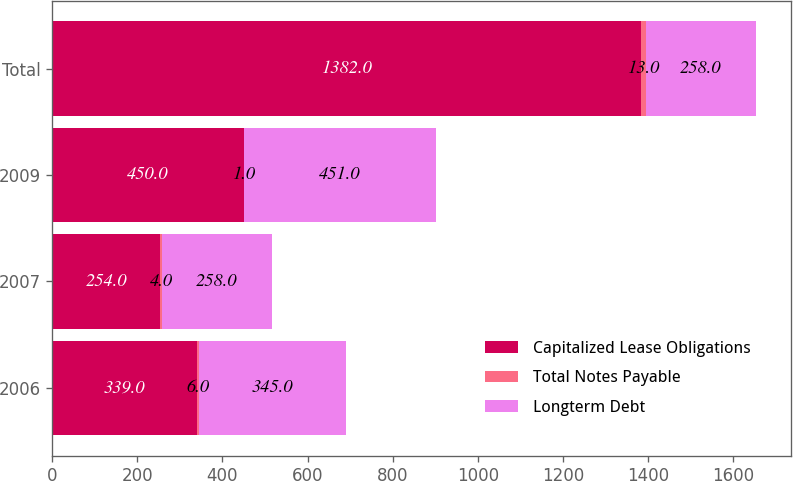Convert chart. <chart><loc_0><loc_0><loc_500><loc_500><stacked_bar_chart><ecel><fcel>2006<fcel>2007<fcel>2009<fcel>Total<nl><fcel>Capitalized Lease Obligations<fcel>339<fcel>254<fcel>450<fcel>1382<nl><fcel>Total Notes Payable<fcel>6<fcel>4<fcel>1<fcel>13<nl><fcel>Longterm Debt<fcel>345<fcel>258<fcel>451<fcel>258<nl></chart> 